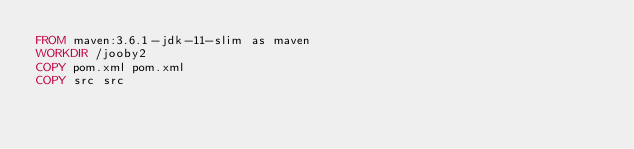<code> <loc_0><loc_0><loc_500><loc_500><_Dockerfile_>FROM maven:3.6.1-jdk-11-slim as maven
WORKDIR /jooby2
COPY pom.xml pom.xml
COPY src src</code> 